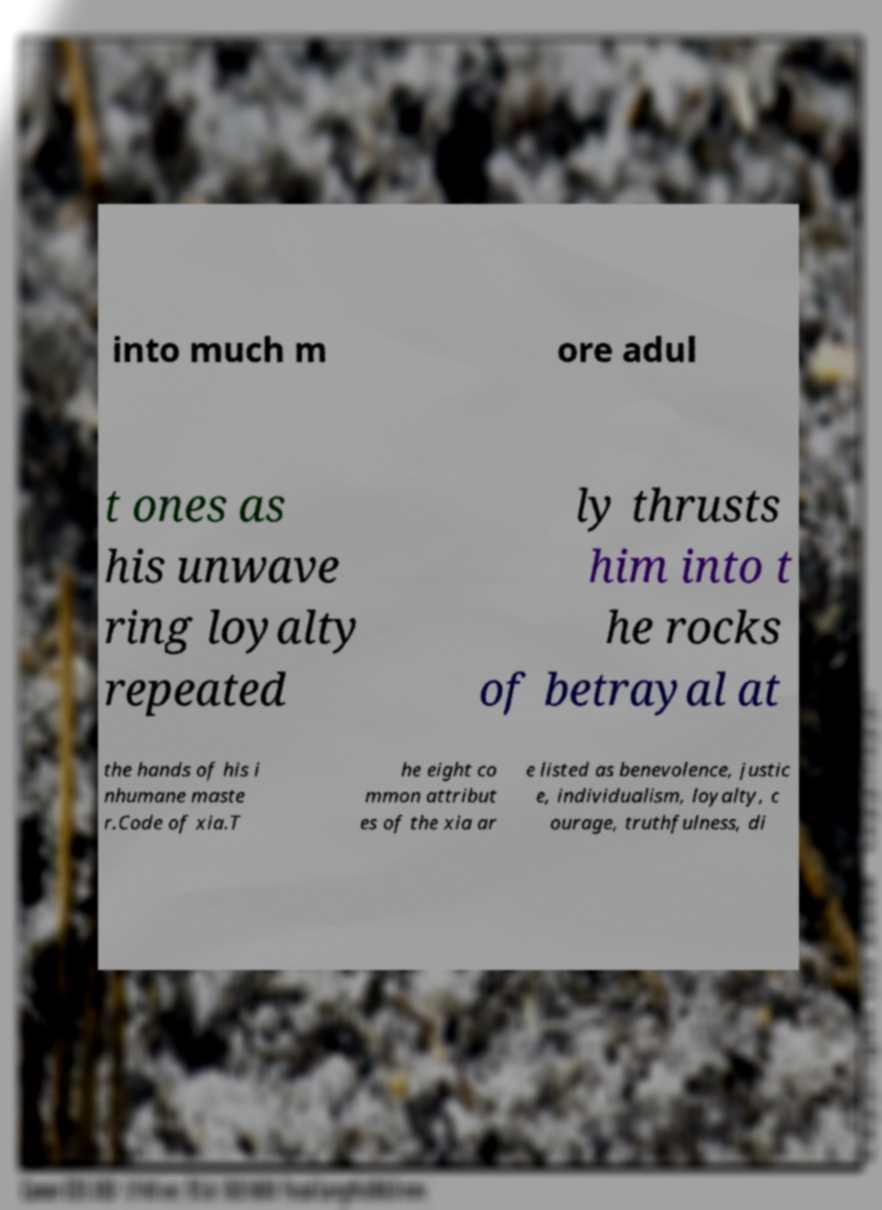For documentation purposes, I need the text within this image transcribed. Could you provide that? into much m ore adul t ones as his unwave ring loyalty repeated ly thrusts him into t he rocks of betrayal at the hands of his i nhumane maste r.Code of xia.T he eight co mmon attribut es of the xia ar e listed as benevolence, justic e, individualism, loyalty, c ourage, truthfulness, di 